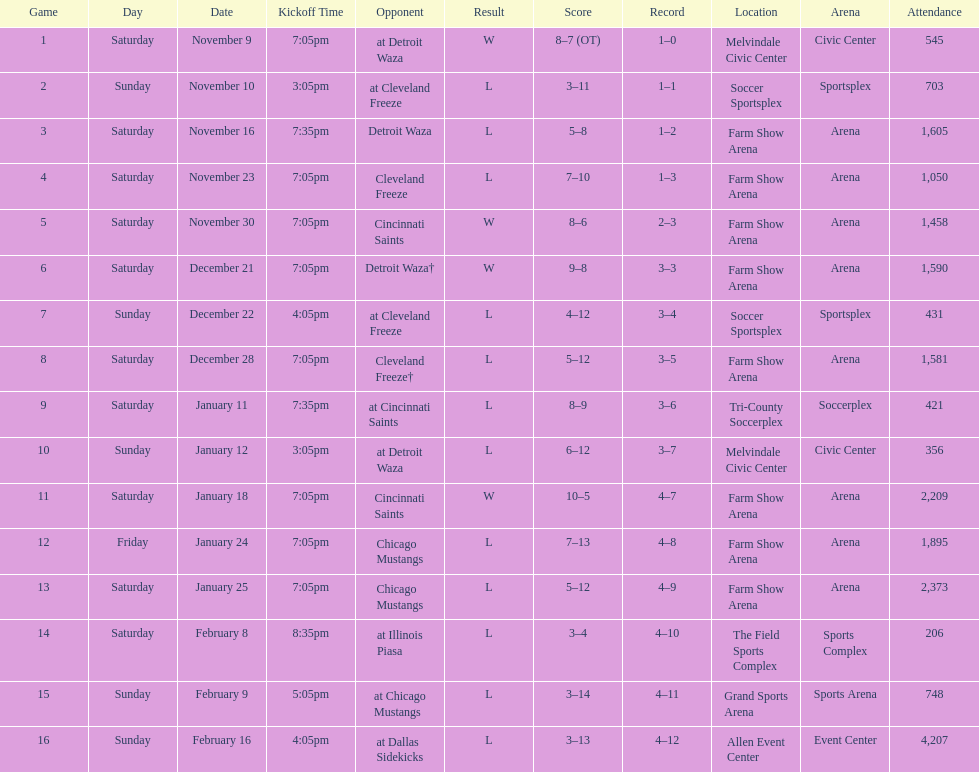How many games did the harrisburg heat win in which they scored eight or more goals? 4. 